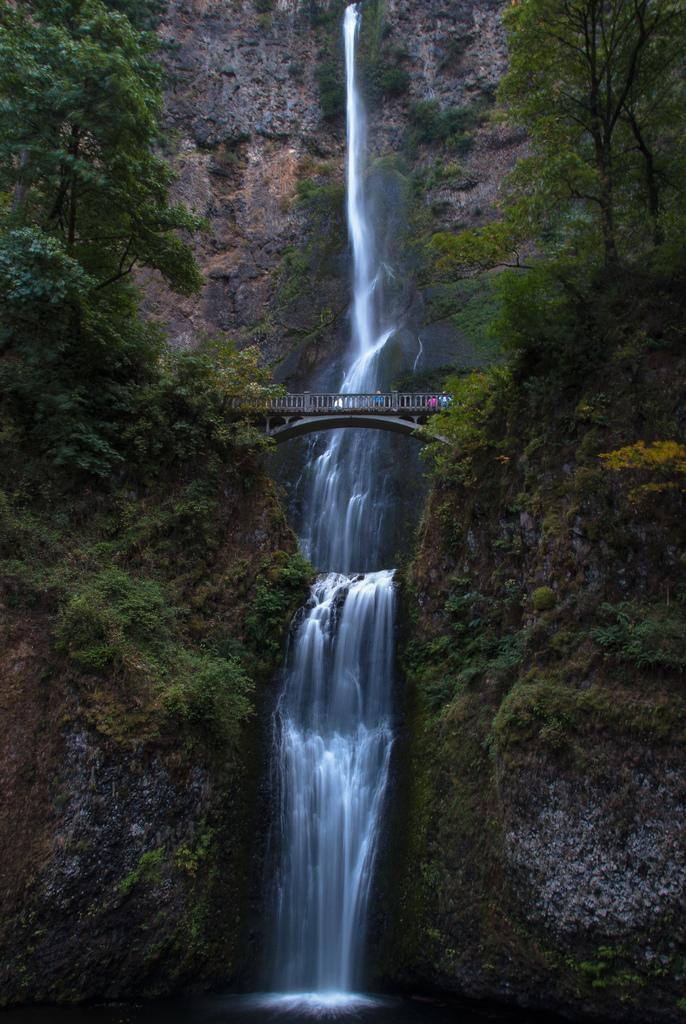What type of structure can be seen in the picture? There is a bridge in the picture. What natural feature is present in the picture? There is a waterfall in the picture. Where does the waterfall originate from? The waterfall is coming from hills. What type of vegetation can be seen in the picture? There are trees in the picture. What type of apples can be seen floating in the waterfall? There are no apples present in the image; it features a bridge, waterfall, hills, and trees. What type of soup is being served on the bridge in the image? There is no soup present in the image; it only features a bridge, waterfall, hills, and trees. 